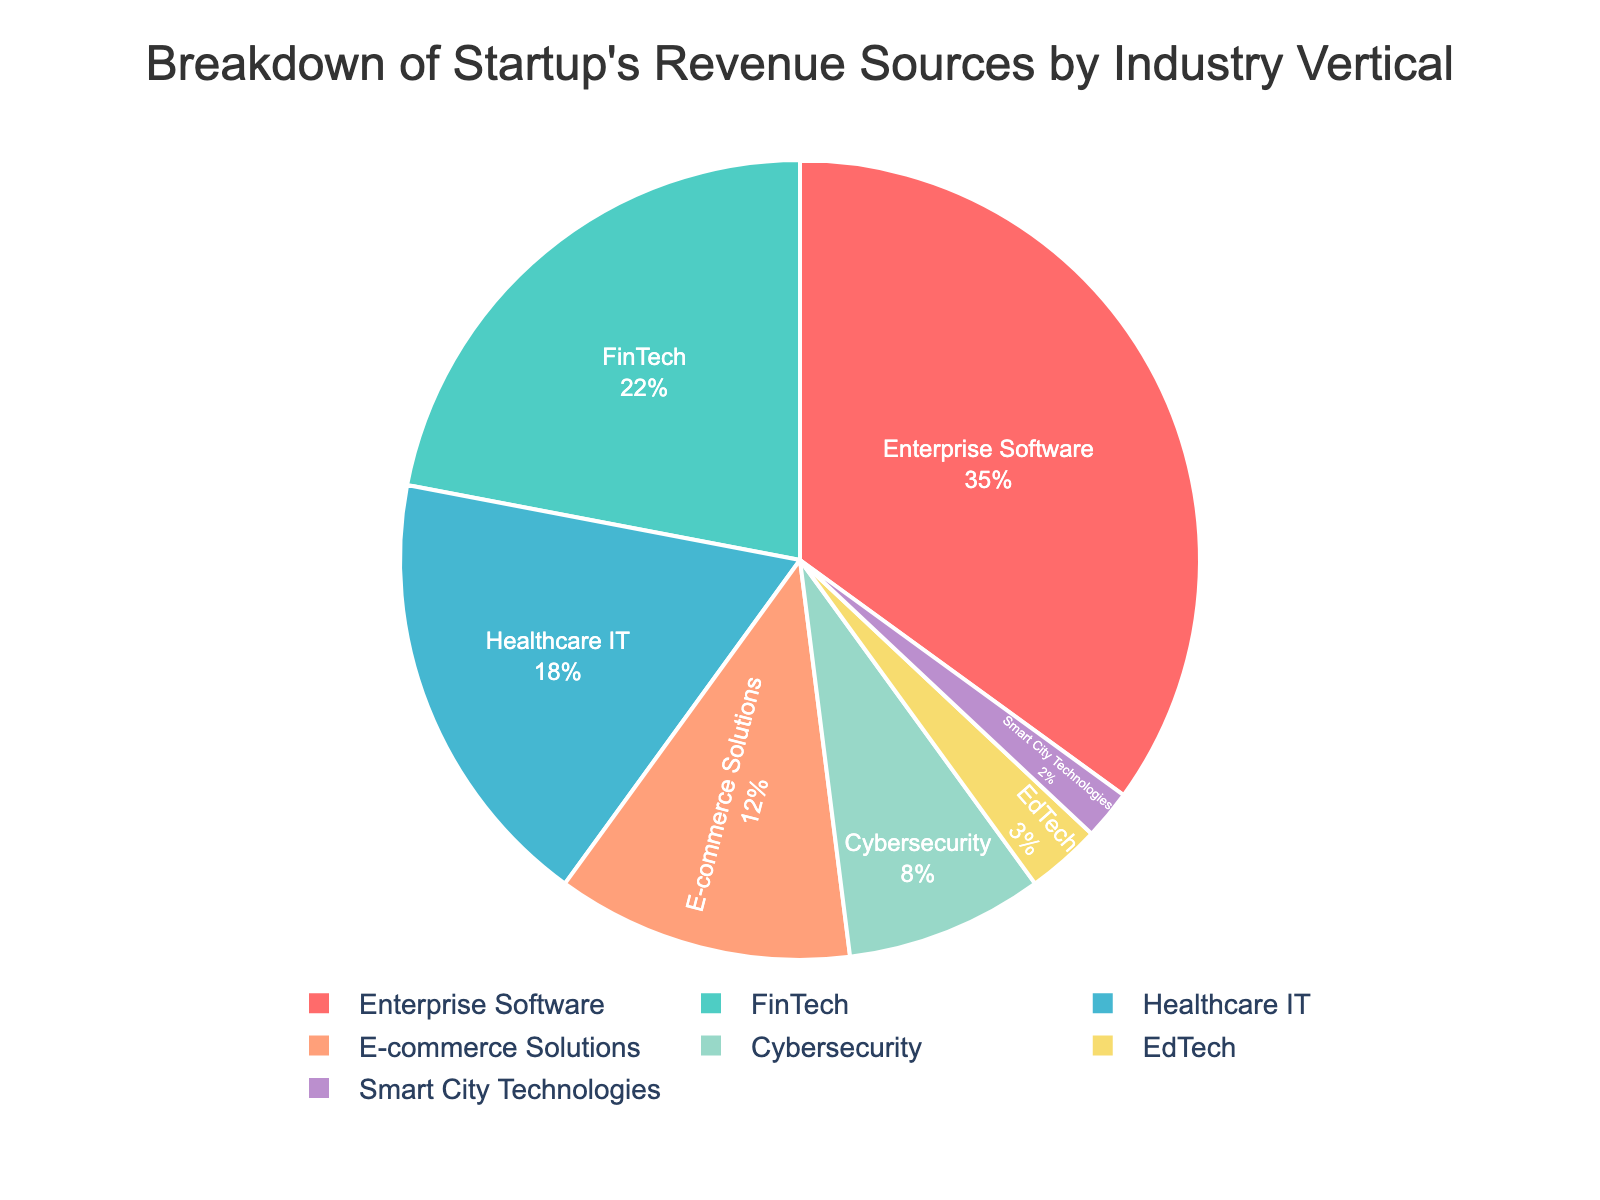Which industry contributes the most to the startup's revenue? The industry with the largest percentage slice in the pie chart represents the highest revenue contribution. Here, Enterprise Software is the largest with 35%.
Answer: Enterprise Software What percentage of the startup’s revenue comes from Healthcare IT and Cybersecurity combined? Sum the percentages for Healthcare IT and Cybersecurity: 18% (Healthcare IT) + 8% (Cybersecurity) = 26%.
Answer: 26% How does the revenue from FinTech compare to that of E-commerce Solutions? Identify the percentage slices for both FinTech and E-commerce Solutions. FinTech has 22% and E-commerce Solutions has 12%. Since 22% > 12%, FinTech contributes more.
Answer: FinTech contributes more Which industry has the smallest revenue share? The smallest slice of the pie chart represents the lowest revenue share. Here, Smart City Technologies is the smallest with 2%.
Answer: Smart City Technologies What's the difference in revenue percentage between Enterprise Software and Healthcare IT? Subtract the percentage for Healthcare IT from Enterprise Software: 35% (Enterprise Software) - 18% (Healthcare IT) = 17%.
Answer: 17% Are there any industry verticals contributing equal percentages to the revenue? Examine each slice's percentage and compare. No two slices have the same value, so there are no equal contributions.
Answer: No Which industry vertical is represented by the light purple color? By visually identifying the color, the light purple slice corresponds to EdTech, which accounts for 3% of the revenue.
Answer: EdTech If you combine the revenue percentages of EdTech and Smart City Technologies, how does it compare to Healthcare IT alone? Sum the percentages for EdTech and Smart City Technologies: 3% (EdTech) + 2% (Smart City Technologies) = 5%. Compare it with Healthcare IT's 18%. Since 5% < 18%, the combined is less.
Answer: Combined is less 